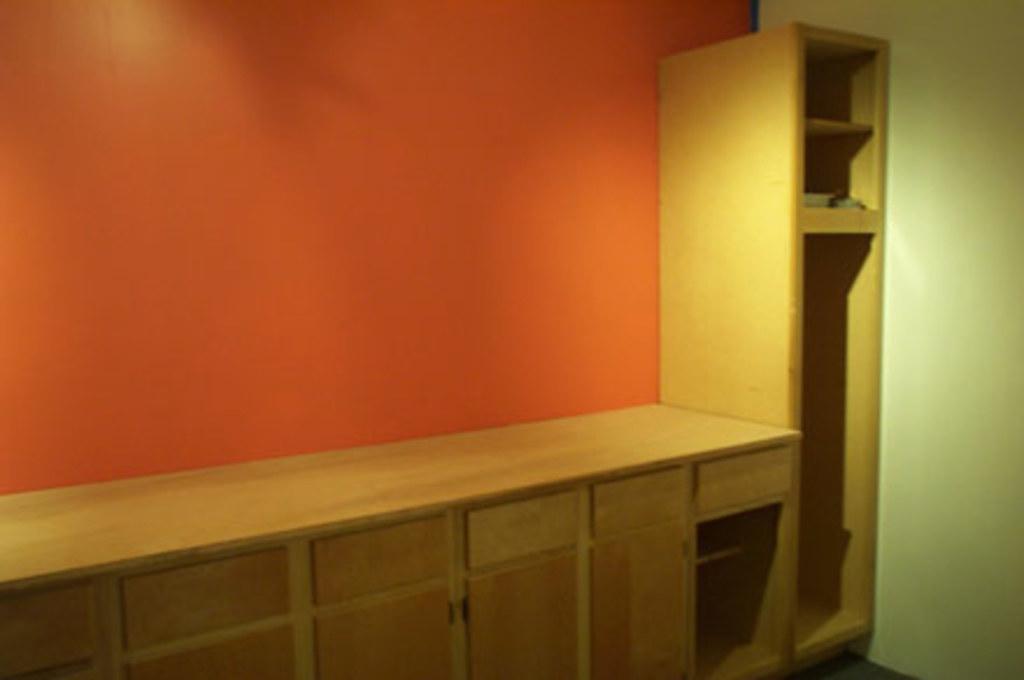In one or two sentences, can you explain what this image depicts? In this image we can see a cupboard. There is wall. To the right side of the image there is wall. 